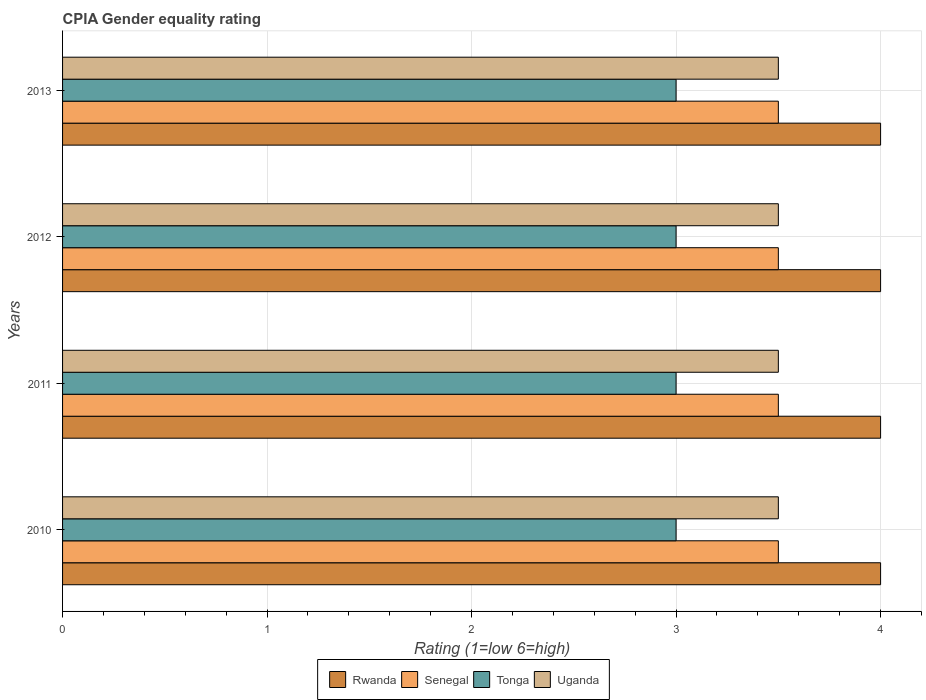How many different coloured bars are there?
Offer a very short reply. 4. Are the number of bars per tick equal to the number of legend labels?
Provide a short and direct response. Yes. How many bars are there on the 4th tick from the top?
Keep it short and to the point. 4. How many bars are there on the 4th tick from the bottom?
Ensure brevity in your answer.  4. What is the label of the 3rd group of bars from the top?
Offer a very short reply. 2011. Across all years, what is the minimum CPIA rating in Uganda?
Your answer should be compact. 3.5. In which year was the CPIA rating in Senegal maximum?
Your answer should be very brief. 2010. In which year was the CPIA rating in Senegal minimum?
Give a very brief answer. 2010. What is the difference between the CPIA rating in Tonga in 2011 and that in 2013?
Your answer should be very brief. 0. What is the difference between the CPIA rating in Tonga in 2013 and the CPIA rating in Senegal in 2012?
Offer a terse response. -0.5. What is the average CPIA rating in Tonga per year?
Ensure brevity in your answer.  3. In the year 2010, what is the difference between the CPIA rating in Uganda and CPIA rating in Tonga?
Provide a succinct answer. 0.5. What is the ratio of the CPIA rating in Senegal in 2011 to that in 2012?
Give a very brief answer. 1. Is it the case that in every year, the sum of the CPIA rating in Senegal and CPIA rating in Tonga is greater than the sum of CPIA rating in Uganda and CPIA rating in Rwanda?
Ensure brevity in your answer.  Yes. What does the 2nd bar from the top in 2013 represents?
Give a very brief answer. Tonga. What does the 1st bar from the bottom in 2010 represents?
Your answer should be compact. Rwanda. How many bars are there?
Ensure brevity in your answer.  16. How many years are there in the graph?
Provide a short and direct response. 4. What is the difference between two consecutive major ticks on the X-axis?
Keep it short and to the point. 1. Are the values on the major ticks of X-axis written in scientific E-notation?
Make the answer very short. No. Does the graph contain any zero values?
Give a very brief answer. No. Does the graph contain grids?
Provide a succinct answer. Yes. How are the legend labels stacked?
Offer a terse response. Horizontal. What is the title of the graph?
Your response must be concise. CPIA Gender equality rating. Does "Cabo Verde" appear as one of the legend labels in the graph?
Provide a short and direct response. No. What is the label or title of the X-axis?
Make the answer very short. Rating (1=low 6=high). What is the label or title of the Y-axis?
Offer a very short reply. Years. What is the Rating (1=low 6=high) of Senegal in 2010?
Provide a succinct answer. 3.5. What is the Rating (1=low 6=high) in Tonga in 2010?
Ensure brevity in your answer.  3. What is the Rating (1=low 6=high) of Uganda in 2010?
Your answer should be very brief. 3.5. What is the Rating (1=low 6=high) of Uganda in 2011?
Your answer should be very brief. 3.5. What is the Rating (1=low 6=high) of Rwanda in 2012?
Your answer should be compact. 4. What is the Rating (1=low 6=high) of Senegal in 2012?
Ensure brevity in your answer.  3.5. What is the Rating (1=low 6=high) of Tonga in 2012?
Make the answer very short. 3. What is the Rating (1=low 6=high) in Uganda in 2012?
Your response must be concise. 3.5. What is the Rating (1=low 6=high) of Senegal in 2013?
Offer a very short reply. 3.5. What is the Rating (1=low 6=high) in Tonga in 2013?
Your response must be concise. 3. What is the Rating (1=low 6=high) of Uganda in 2013?
Your response must be concise. 3.5. Across all years, what is the maximum Rating (1=low 6=high) in Tonga?
Make the answer very short. 3. Across all years, what is the minimum Rating (1=low 6=high) in Rwanda?
Offer a very short reply. 4. Across all years, what is the minimum Rating (1=low 6=high) in Tonga?
Ensure brevity in your answer.  3. What is the total Rating (1=low 6=high) in Uganda in the graph?
Keep it short and to the point. 14. What is the difference between the Rating (1=low 6=high) in Senegal in 2010 and that in 2011?
Your answer should be very brief. 0. What is the difference between the Rating (1=low 6=high) in Uganda in 2010 and that in 2011?
Your response must be concise. 0. What is the difference between the Rating (1=low 6=high) in Tonga in 2010 and that in 2012?
Offer a very short reply. 0. What is the difference between the Rating (1=low 6=high) of Senegal in 2010 and that in 2013?
Offer a very short reply. 0. What is the difference between the Rating (1=low 6=high) in Tonga in 2010 and that in 2013?
Your answer should be compact. 0. What is the difference between the Rating (1=low 6=high) of Uganda in 2010 and that in 2013?
Keep it short and to the point. 0. What is the difference between the Rating (1=low 6=high) of Senegal in 2011 and that in 2013?
Make the answer very short. 0. What is the difference between the Rating (1=low 6=high) in Tonga in 2011 and that in 2013?
Your response must be concise. 0. What is the difference between the Rating (1=low 6=high) of Uganda in 2011 and that in 2013?
Keep it short and to the point. 0. What is the difference between the Rating (1=low 6=high) of Rwanda in 2012 and that in 2013?
Your answer should be compact. 0. What is the difference between the Rating (1=low 6=high) in Tonga in 2012 and that in 2013?
Ensure brevity in your answer.  0. What is the difference between the Rating (1=low 6=high) of Rwanda in 2010 and the Rating (1=low 6=high) of Uganda in 2011?
Provide a short and direct response. 0.5. What is the difference between the Rating (1=low 6=high) of Senegal in 2010 and the Rating (1=low 6=high) of Tonga in 2011?
Your response must be concise. 0.5. What is the difference between the Rating (1=low 6=high) of Rwanda in 2010 and the Rating (1=low 6=high) of Uganda in 2013?
Offer a terse response. 0.5. What is the difference between the Rating (1=low 6=high) of Senegal in 2010 and the Rating (1=low 6=high) of Tonga in 2013?
Provide a succinct answer. 0.5. What is the difference between the Rating (1=low 6=high) in Tonga in 2010 and the Rating (1=low 6=high) in Uganda in 2013?
Offer a very short reply. -0.5. What is the difference between the Rating (1=low 6=high) in Rwanda in 2011 and the Rating (1=low 6=high) in Senegal in 2012?
Give a very brief answer. 0.5. What is the difference between the Rating (1=low 6=high) of Senegal in 2011 and the Rating (1=low 6=high) of Uganda in 2012?
Keep it short and to the point. 0. What is the difference between the Rating (1=low 6=high) of Tonga in 2011 and the Rating (1=low 6=high) of Uganda in 2012?
Give a very brief answer. -0.5. What is the difference between the Rating (1=low 6=high) in Rwanda in 2011 and the Rating (1=low 6=high) in Uganda in 2013?
Offer a terse response. 0.5. What is the difference between the Rating (1=low 6=high) of Tonga in 2011 and the Rating (1=low 6=high) of Uganda in 2013?
Make the answer very short. -0.5. What is the difference between the Rating (1=low 6=high) in Senegal in 2012 and the Rating (1=low 6=high) in Tonga in 2013?
Your answer should be compact. 0.5. What is the difference between the Rating (1=low 6=high) in Senegal in 2012 and the Rating (1=low 6=high) in Uganda in 2013?
Give a very brief answer. 0. What is the average Rating (1=low 6=high) of Rwanda per year?
Provide a short and direct response. 4. What is the average Rating (1=low 6=high) of Tonga per year?
Your response must be concise. 3. In the year 2010, what is the difference between the Rating (1=low 6=high) in Senegal and Rating (1=low 6=high) in Tonga?
Give a very brief answer. 0.5. In the year 2011, what is the difference between the Rating (1=low 6=high) of Rwanda and Rating (1=low 6=high) of Uganda?
Give a very brief answer. 0.5. In the year 2011, what is the difference between the Rating (1=low 6=high) of Senegal and Rating (1=low 6=high) of Uganda?
Offer a terse response. 0. In the year 2011, what is the difference between the Rating (1=low 6=high) of Tonga and Rating (1=low 6=high) of Uganda?
Provide a succinct answer. -0.5. In the year 2012, what is the difference between the Rating (1=low 6=high) in Rwanda and Rating (1=low 6=high) in Senegal?
Provide a succinct answer. 0.5. In the year 2012, what is the difference between the Rating (1=low 6=high) in Rwanda and Rating (1=low 6=high) in Uganda?
Offer a very short reply. 0.5. In the year 2012, what is the difference between the Rating (1=low 6=high) in Senegal and Rating (1=low 6=high) in Uganda?
Give a very brief answer. 0. In the year 2013, what is the difference between the Rating (1=low 6=high) in Rwanda and Rating (1=low 6=high) in Senegal?
Ensure brevity in your answer.  0.5. In the year 2013, what is the difference between the Rating (1=low 6=high) in Senegal and Rating (1=low 6=high) in Tonga?
Provide a succinct answer. 0.5. In the year 2013, what is the difference between the Rating (1=low 6=high) of Tonga and Rating (1=low 6=high) of Uganda?
Keep it short and to the point. -0.5. What is the ratio of the Rating (1=low 6=high) in Rwanda in 2010 to that in 2011?
Your answer should be very brief. 1. What is the ratio of the Rating (1=low 6=high) in Tonga in 2010 to that in 2011?
Ensure brevity in your answer.  1. What is the ratio of the Rating (1=low 6=high) of Uganda in 2010 to that in 2011?
Offer a very short reply. 1. What is the ratio of the Rating (1=low 6=high) of Rwanda in 2010 to that in 2012?
Your response must be concise. 1. What is the ratio of the Rating (1=low 6=high) in Tonga in 2010 to that in 2012?
Ensure brevity in your answer.  1. What is the ratio of the Rating (1=low 6=high) of Rwanda in 2010 to that in 2013?
Give a very brief answer. 1. What is the ratio of the Rating (1=low 6=high) in Tonga in 2010 to that in 2013?
Provide a short and direct response. 1. What is the ratio of the Rating (1=low 6=high) in Senegal in 2011 to that in 2012?
Offer a terse response. 1. What is the ratio of the Rating (1=low 6=high) of Tonga in 2011 to that in 2012?
Make the answer very short. 1. What is the ratio of the Rating (1=low 6=high) in Uganda in 2011 to that in 2012?
Your answer should be compact. 1. What is the ratio of the Rating (1=low 6=high) in Rwanda in 2012 to that in 2013?
Your response must be concise. 1. What is the ratio of the Rating (1=low 6=high) in Senegal in 2012 to that in 2013?
Give a very brief answer. 1. What is the ratio of the Rating (1=low 6=high) of Uganda in 2012 to that in 2013?
Give a very brief answer. 1. What is the difference between the highest and the second highest Rating (1=low 6=high) of Rwanda?
Ensure brevity in your answer.  0. What is the difference between the highest and the second highest Rating (1=low 6=high) in Uganda?
Ensure brevity in your answer.  0. What is the difference between the highest and the lowest Rating (1=low 6=high) in Rwanda?
Ensure brevity in your answer.  0. What is the difference between the highest and the lowest Rating (1=low 6=high) of Senegal?
Offer a very short reply. 0. 